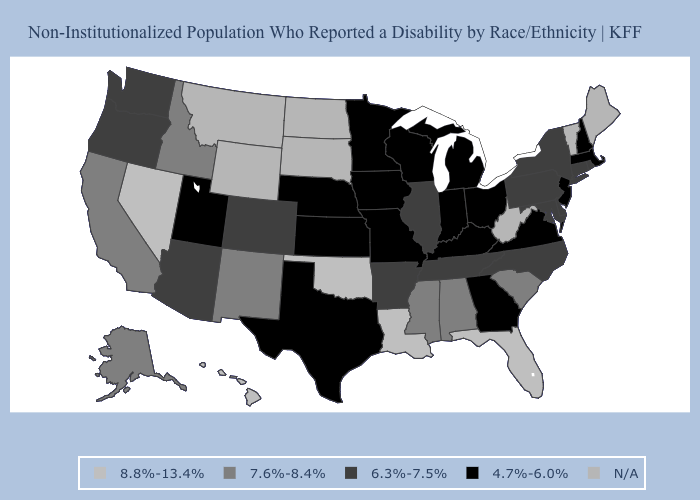Which states hav the highest value in the MidWest?
Quick response, please. Illinois. Among the states that border Vermont , does New York have the highest value?
Keep it brief. Yes. Which states hav the highest value in the South?
Give a very brief answer. Florida, Louisiana, Oklahoma. Name the states that have a value in the range 6.3%-7.5%?
Concise answer only. Arizona, Arkansas, Colorado, Connecticut, Delaware, Illinois, Maryland, New York, North Carolina, Oregon, Pennsylvania, Rhode Island, Tennessee, Washington. What is the value of South Dakota?
Concise answer only. N/A. Does Michigan have the lowest value in the USA?
Give a very brief answer. Yes. What is the value of Colorado?
Concise answer only. 6.3%-7.5%. What is the lowest value in the USA?
Concise answer only. 4.7%-6.0%. Among the states that border Vermont , does New York have the highest value?
Short answer required. Yes. What is the lowest value in the USA?
Concise answer only. 4.7%-6.0%. What is the value of Kansas?
Quick response, please. 4.7%-6.0%. Does Michigan have the highest value in the USA?
Concise answer only. No. What is the lowest value in states that border Montana?
Concise answer only. 7.6%-8.4%. 